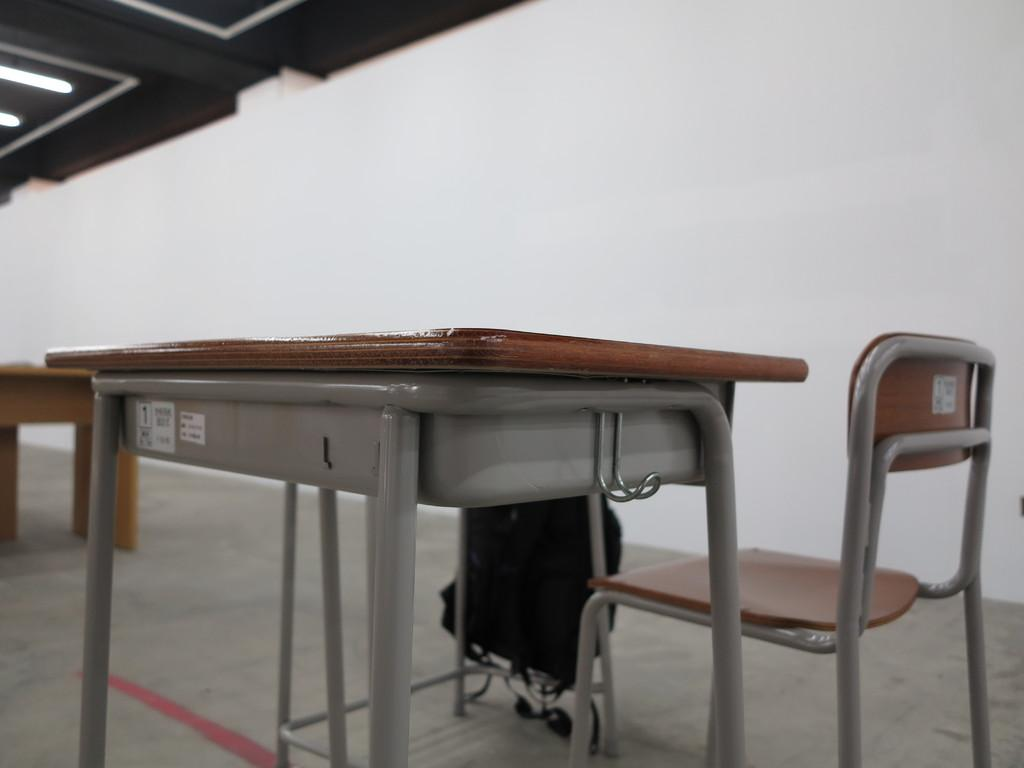What type of furniture is present in the image? There is a table and a chair in the image. What is placed on the table? There is a bag on the table. Can you see any other furniture in the image? There is another table partially visible in the image. What can be seen on the ceiling in the image? There are lights on the ceiling. What time of day is it in the image, and is the farmer present? The time of day cannot be determined from the image, and there is no farmer present in the image. How many legs does the chair have in the image? The number of legs on the chair cannot be determined from the image, as the chair is not fully visible. 